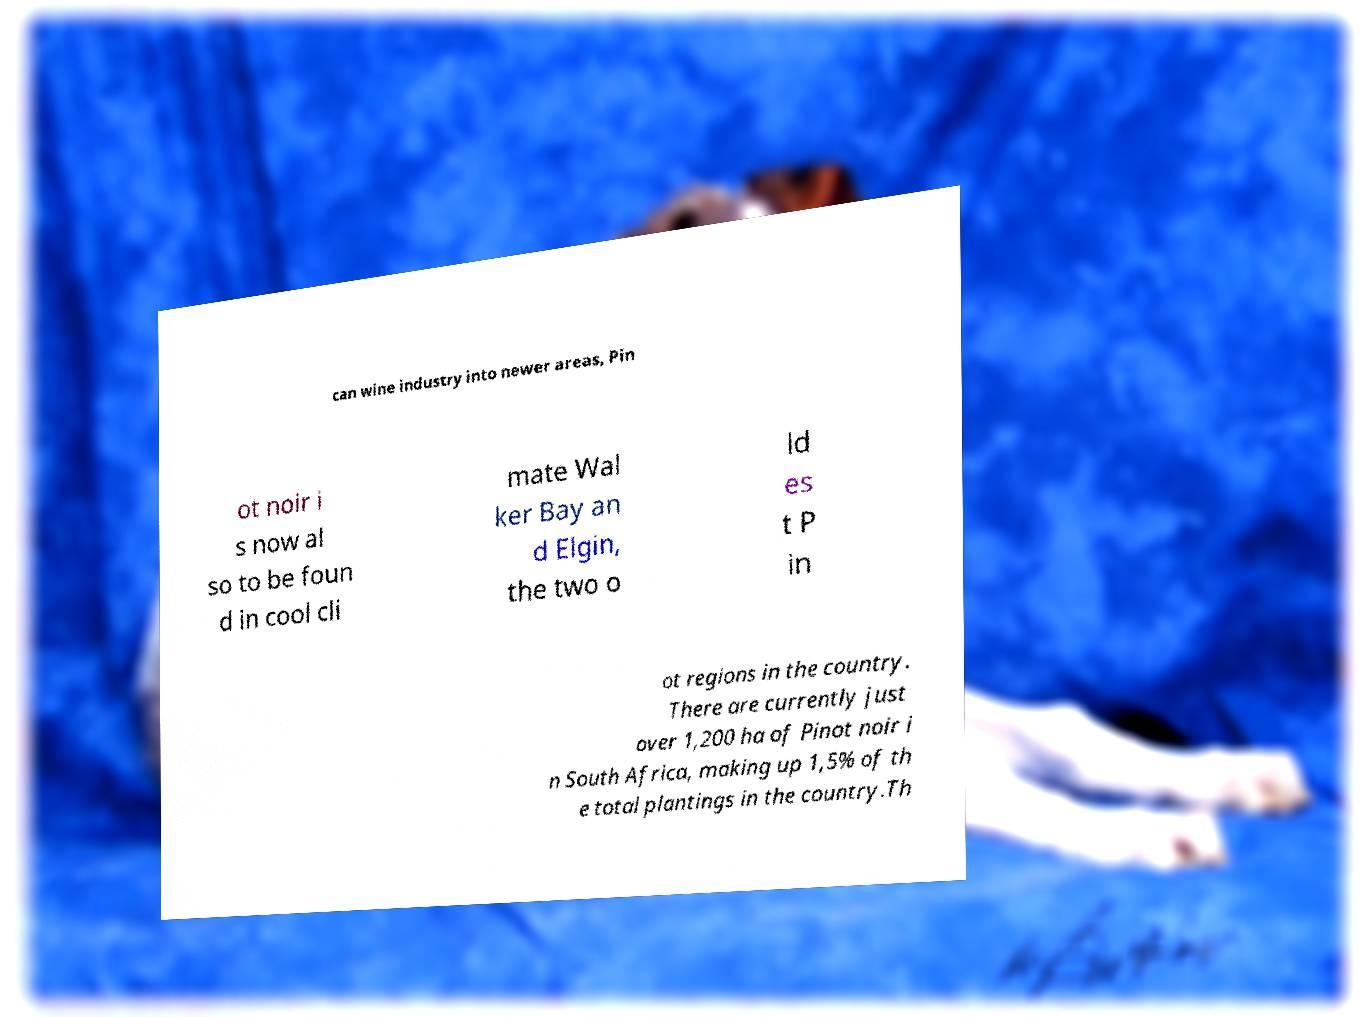What messages or text are displayed in this image? I need them in a readable, typed format. can wine industry into newer areas, Pin ot noir i s now al so to be foun d in cool cli mate Wal ker Bay an d Elgin, the two o ld es t P in ot regions in the country. There are currently just over 1,200 ha of Pinot noir i n South Africa, making up 1,5% of th e total plantings in the country.Th 